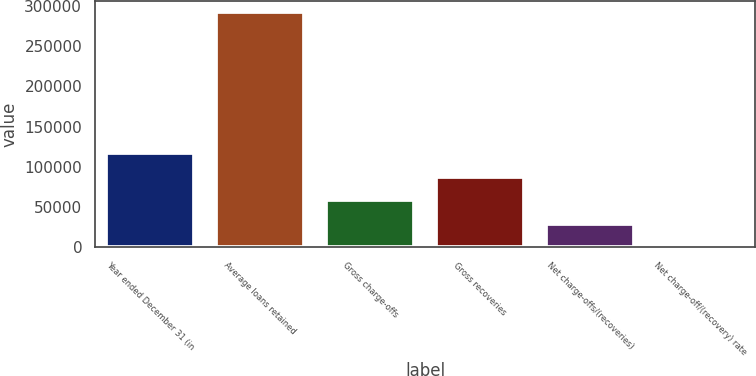Convert chart. <chart><loc_0><loc_0><loc_500><loc_500><bar_chart><fcel>Year ended December 31 (in<fcel>Average loans retained<fcel>Gross charge-offs<fcel>Gross recoveries<fcel>Net charge-offs/(recoveries)<fcel>Net charge-off/(recovery) rate<nl><fcel>116792<fcel>291980<fcel>58396<fcel>87594<fcel>29198<fcel>0.06<nl></chart> 